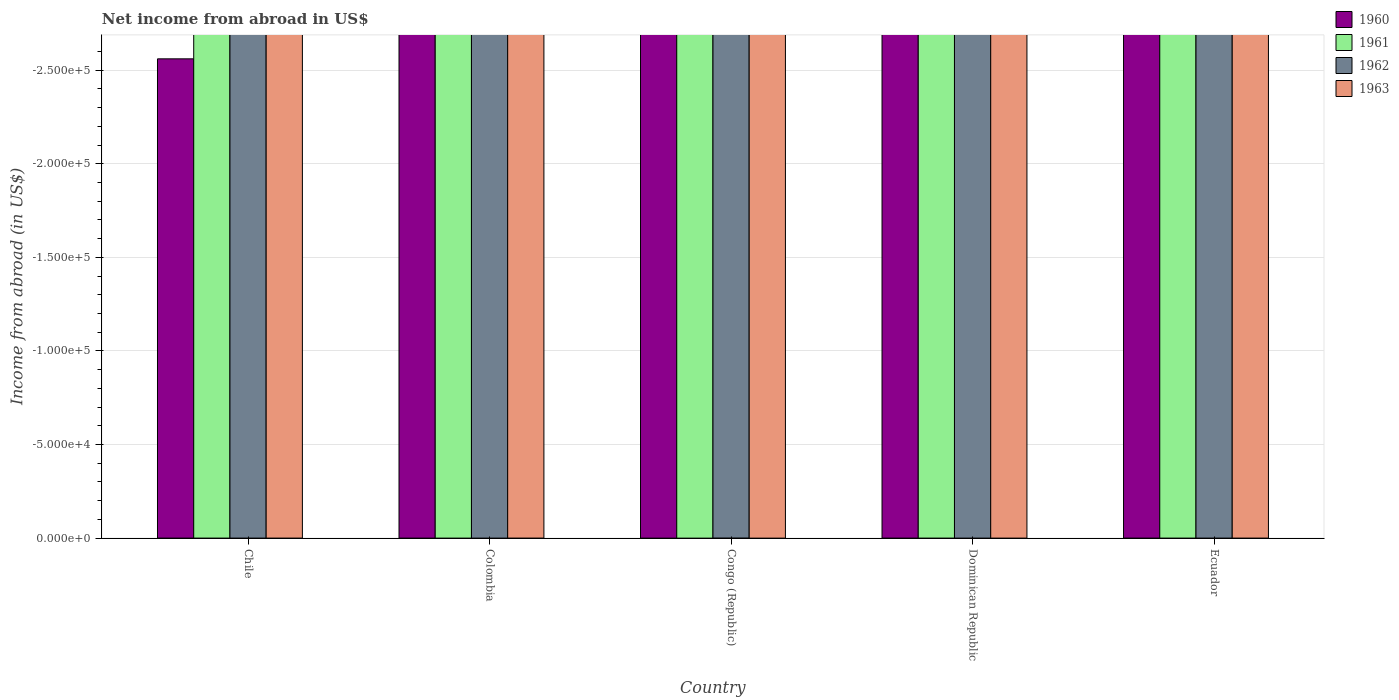How many different coloured bars are there?
Offer a terse response. 0. How many bars are there on the 5th tick from the left?
Offer a terse response. 0. How many bars are there on the 4th tick from the right?
Keep it short and to the point. 0. What is the label of the 4th group of bars from the left?
Your answer should be very brief. Dominican Republic. Across all countries, what is the minimum net income from abroad in 1960?
Your answer should be very brief. 0. What is the difference between the net income from abroad in 1963 in Congo (Republic) and the net income from abroad in 1961 in Dominican Republic?
Offer a very short reply. 0. What is the average net income from abroad in 1962 per country?
Your response must be concise. 0. In how many countries, is the net income from abroad in 1961 greater than the average net income from abroad in 1961 taken over all countries?
Keep it short and to the point. 0. Is it the case that in every country, the sum of the net income from abroad in 1960 and net income from abroad in 1963 is greater than the sum of net income from abroad in 1961 and net income from abroad in 1962?
Your answer should be very brief. No. Is it the case that in every country, the sum of the net income from abroad in 1960 and net income from abroad in 1963 is greater than the net income from abroad in 1962?
Keep it short and to the point. No. How many bars are there?
Make the answer very short. 0. What is the difference between two consecutive major ticks on the Y-axis?
Provide a short and direct response. 5.00e+04. Are the values on the major ticks of Y-axis written in scientific E-notation?
Your answer should be compact. Yes. Where does the legend appear in the graph?
Your answer should be compact. Top right. How many legend labels are there?
Provide a succinct answer. 4. How are the legend labels stacked?
Your response must be concise. Vertical. What is the title of the graph?
Your response must be concise. Net income from abroad in US$. Does "1993" appear as one of the legend labels in the graph?
Offer a very short reply. No. What is the label or title of the X-axis?
Provide a succinct answer. Country. What is the label or title of the Y-axis?
Make the answer very short. Income from abroad (in US$). What is the Income from abroad (in US$) of 1961 in Chile?
Provide a short and direct response. 0. What is the Income from abroad (in US$) of 1962 in Chile?
Provide a succinct answer. 0. What is the Income from abroad (in US$) in 1963 in Chile?
Provide a short and direct response. 0. What is the Income from abroad (in US$) in 1960 in Colombia?
Give a very brief answer. 0. What is the Income from abroad (in US$) of 1962 in Colombia?
Offer a terse response. 0. What is the Income from abroad (in US$) in 1960 in Congo (Republic)?
Keep it short and to the point. 0. What is the Income from abroad (in US$) of 1962 in Congo (Republic)?
Provide a succinct answer. 0. What is the Income from abroad (in US$) in 1963 in Congo (Republic)?
Offer a terse response. 0. What is the Income from abroad (in US$) of 1960 in Dominican Republic?
Your response must be concise. 0. What is the Income from abroad (in US$) of 1961 in Dominican Republic?
Make the answer very short. 0. What is the Income from abroad (in US$) of 1963 in Dominican Republic?
Give a very brief answer. 0. What is the Income from abroad (in US$) in 1960 in Ecuador?
Keep it short and to the point. 0. What is the Income from abroad (in US$) in 1961 in Ecuador?
Offer a terse response. 0. What is the Income from abroad (in US$) in 1963 in Ecuador?
Your answer should be compact. 0. What is the total Income from abroad (in US$) of 1962 in the graph?
Ensure brevity in your answer.  0. 